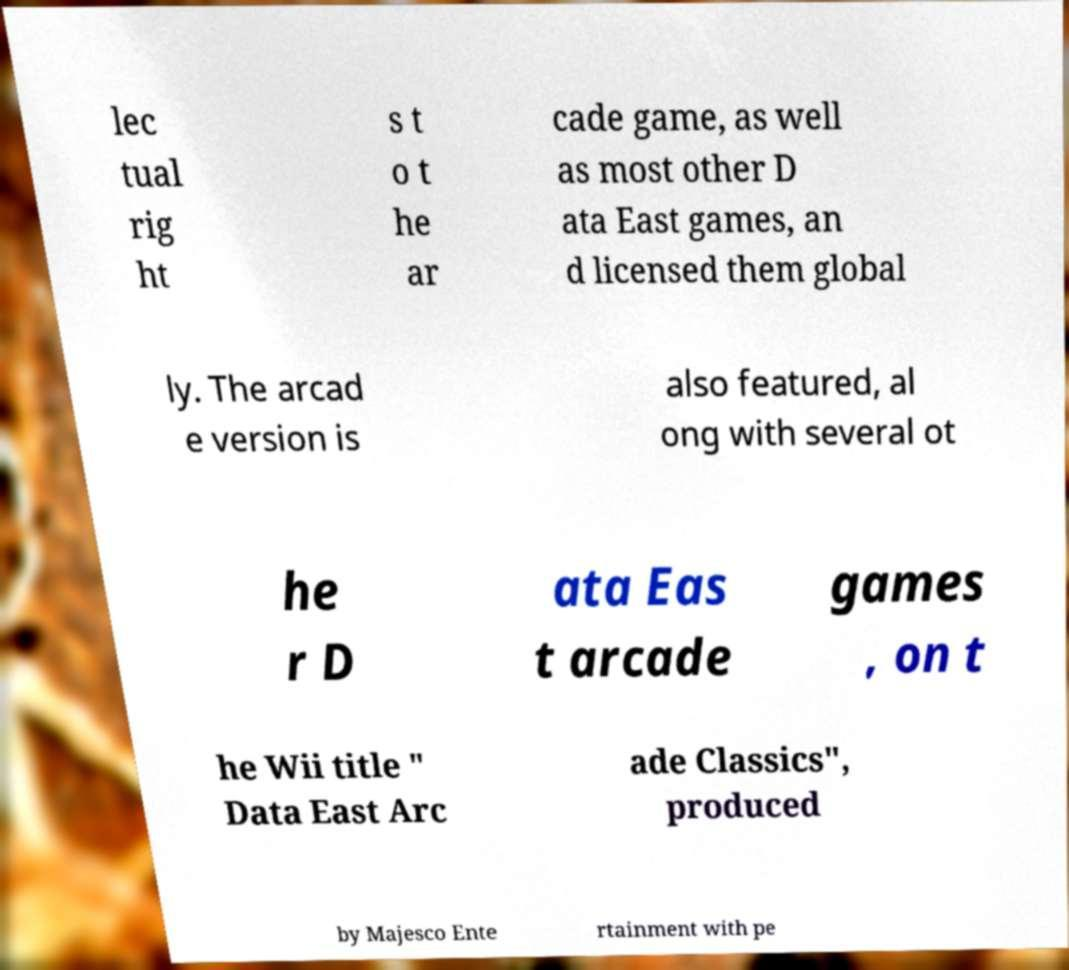Could you assist in decoding the text presented in this image and type it out clearly? lec tual rig ht s t o t he ar cade game, as well as most other D ata East games, an d licensed them global ly. The arcad e version is also featured, al ong with several ot he r D ata Eas t arcade games , on t he Wii title " Data East Arc ade Classics", produced by Majesco Ente rtainment with pe 